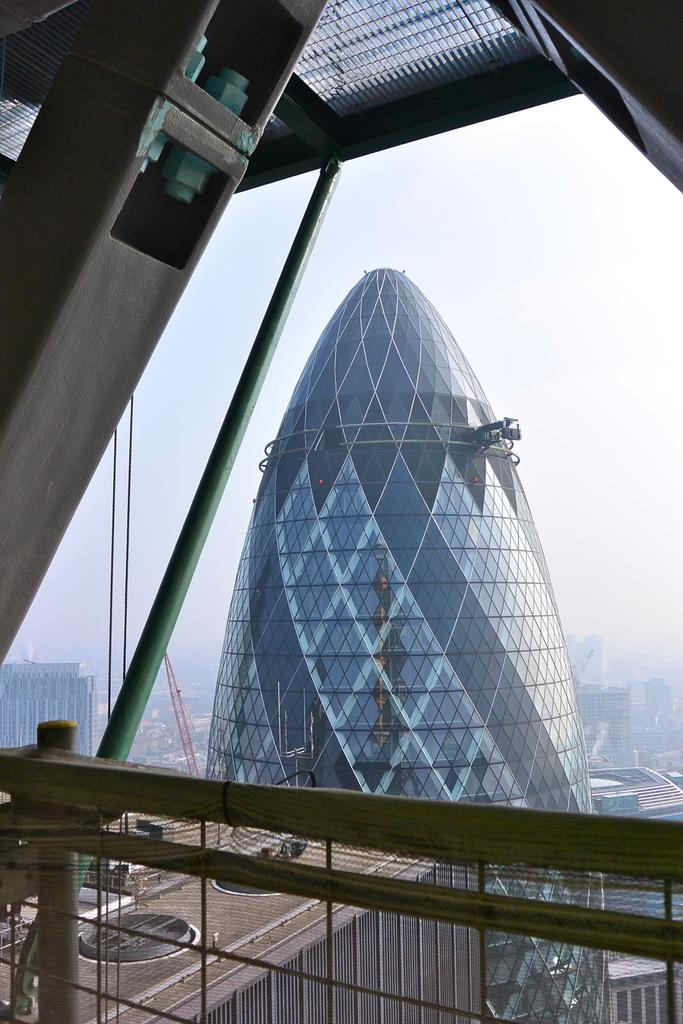What type of structures can be seen in the image? There are buildings in the image. What is located at the bottom of the image? There is a fence at the bottom of the image. Can you describe any specific features of the buildings? A metal rod is attached to the roof of a building. What can be seen in the background of the image? The sky is visible in the background of the image. Where is the family sitting in the image? There is no family present in the image. What type of seed is growing near the fence in the image? There is no seed or plant visible near the fence in the image. 